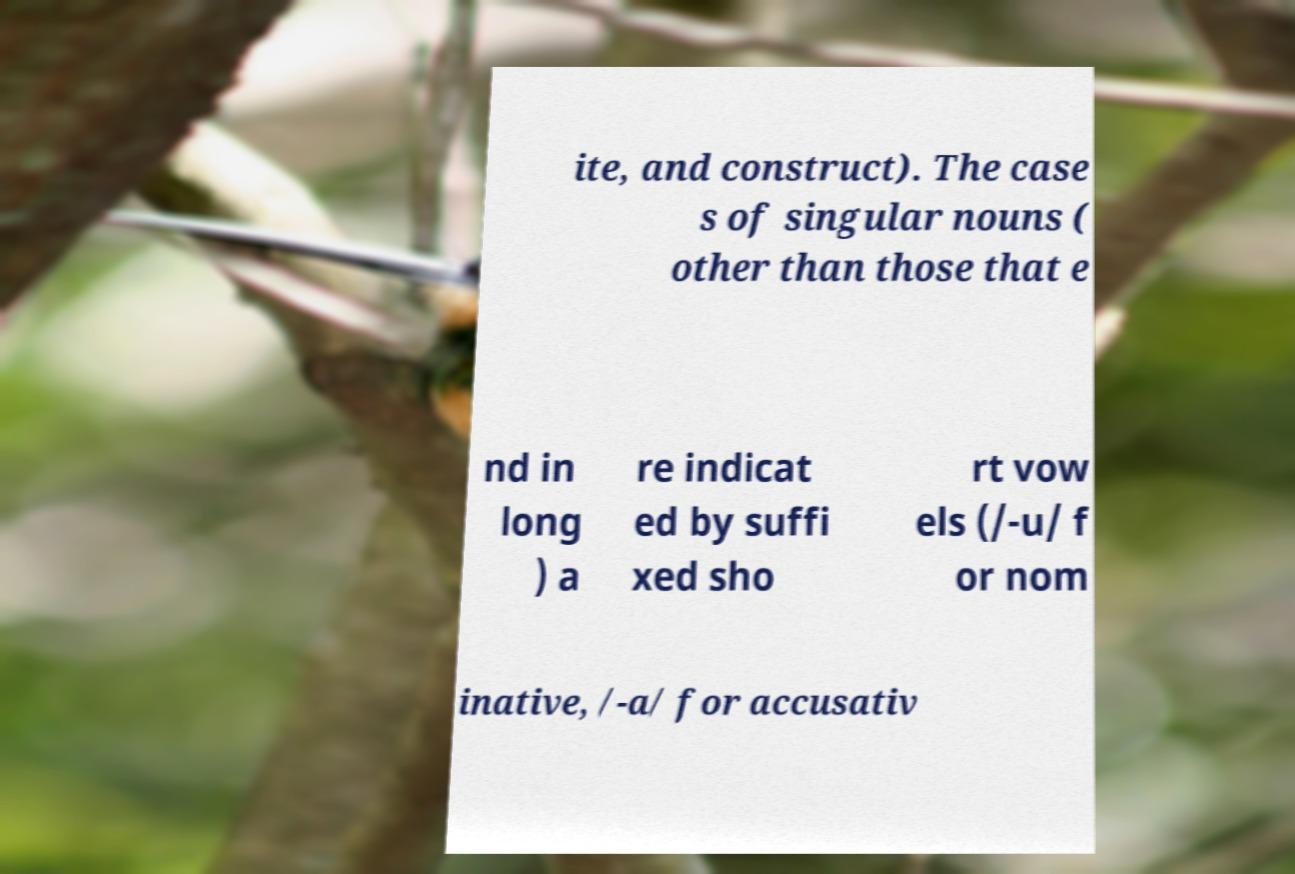Can you accurately transcribe the text from the provided image for me? ite, and construct). The case s of singular nouns ( other than those that e nd in long ) a re indicat ed by suffi xed sho rt vow els (/-u/ f or nom inative, /-a/ for accusativ 